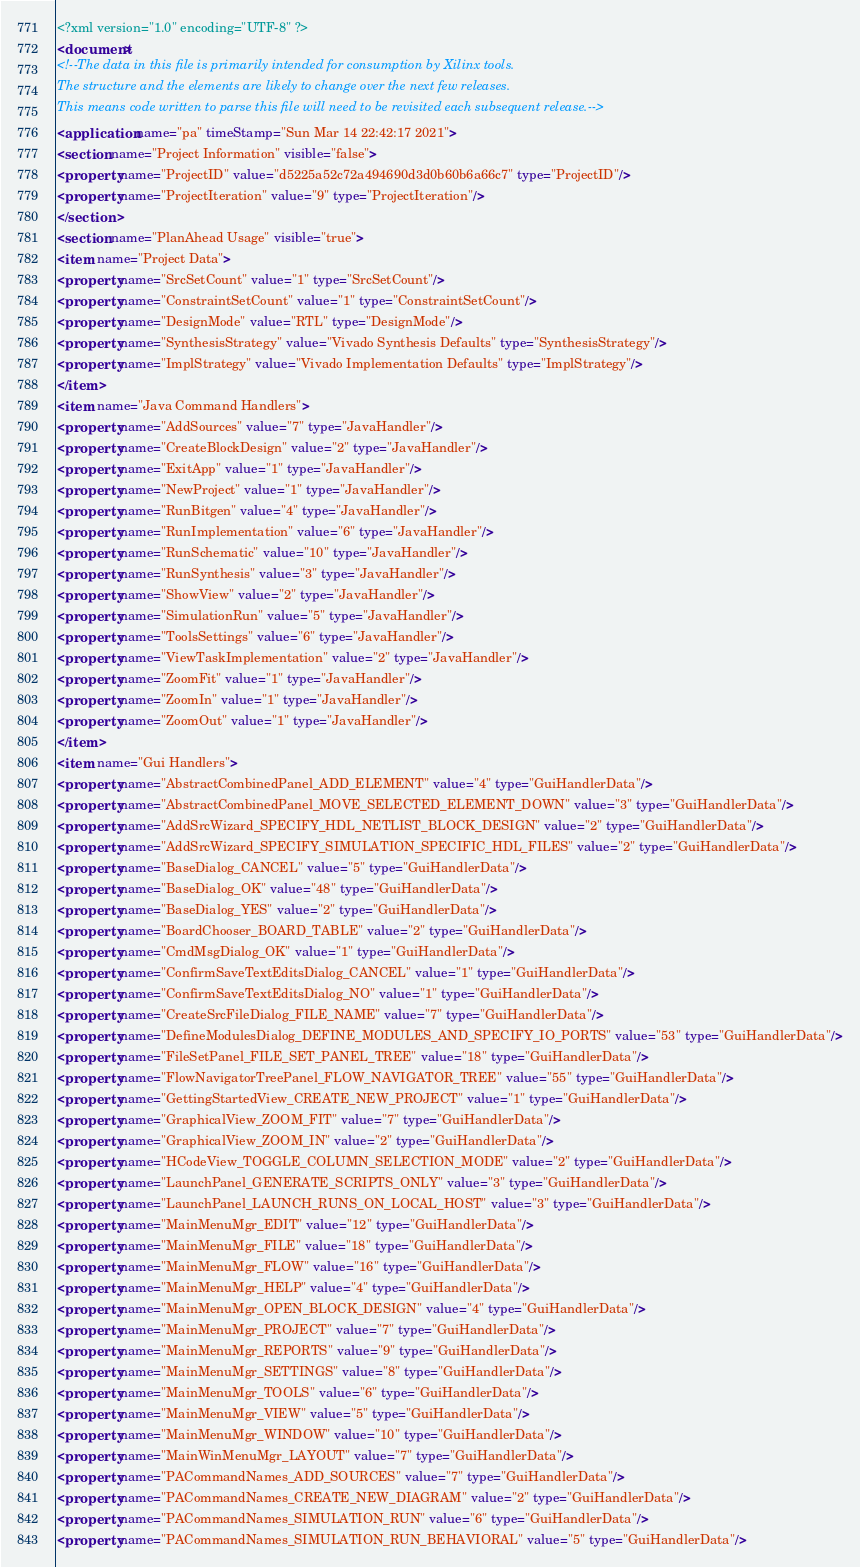Convert code to text. <code><loc_0><loc_0><loc_500><loc_500><_XML_><?xml version="1.0" encoding="UTF-8" ?>
<document>
<!--The data in this file is primarily intended for consumption by Xilinx tools.
The structure and the elements are likely to change over the next few releases.
This means code written to parse this file will need to be revisited each subsequent release.-->
<application name="pa" timeStamp="Sun Mar 14 22:42:17 2021">
<section name="Project Information" visible="false">
<property name="ProjectID" value="d5225a52c72a494690d3d0b60b6a66c7" type="ProjectID"/>
<property name="ProjectIteration" value="9" type="ProjectIteration"/>
</section>
<section name="PlanAhead Usage" visible="true">
<item name="Project Data">
<property name="SrcSetCount" value="1" type="SrcSetCount"/>
<property name="ConstraintSetCount" value="1" type="ConstraintSetCount"/>
<property name="DesignMode" value="RTL" type="DesignMode"/>
<property name="SynthesisStrategy" value="Vivado Synthesis Defaults" type="SynthesisStrategy"/>
<property name="ImplStrategy" value="Vivado Implementation Defaults" type="ImplStrategy"/>
</item>
<item name="Java Command Handlers">
<property name="AddSources" value="7" type="JavaHandler"/>
<property name="CreateBlockDesign" value="2" type="JavaHandler"/>
<property name="ExitApp" value="1" type="JavaHandler"/>
<property name="NewProject" value="1" type="JavaHandler"/>
<property name="RunBitgen" value="4" type="JavaHandler"/>
<property name="RunImplementation" value="6" type="JavaHandler"/>
<property name="RunSchematic" value="10" type="JavaHandler"/>
<property name="RunSynthesis" value="3" type="JavaHandler"/>
<property name="ShowView" value="2" type="JavaHandler"/>
<property name="SimulationRun" value="5" type="JavaHandler"/>
<property name="ToolsSettings" value="6" type="JavaHandler"/>
<property name="ViewTaskImplementation" value="2" type="JavaHandler"/>
<property name="ZoomFit" value="1" type="JavaHandler"/>
<property name="ZoomIn" value="1" type="JavaHandler"/>
<property name="ZoomOut" value="1" type="JavaHandler"/>
</item>
<item name="Gui Handlers">
<property name="AbstractCombinedPanel_ADD_ELEMENT" value="4" type="GuiHandlerData"/>
<property name="AbstractCombinedPanel_MOVE_SELECTED_ELEMENT_DOWN" value="3" type="GuiHandlerData"/>
<property name="AddSrcWizard_SPECIFY_HDL_NETLIST_BLOCK_DESIGN" value="2" type="GuiHandlerData"/>
<property name="AddSrcWizard_SPECIFY_SIMULATION_SPECIFIC_HDL_FILES" value="2" type="GuiHandlerData"/>
<property name="BaseDialog_CANCEL" value="5" type="GuiHandlerData"/>
<property name="BaseDialog_OK" value="48" type="GuiHandlerData"/>
<property name="BaseDialog_YES" value="2" type="GuiHandlerData"/>
<property name="BoardChooser_BOARD_TABLE" value="2" type="GuiHandlerData"/>
<property name="CmdMsgDialog_OK" value="1" type="GuiHandlerData"/>
<property name="ConfirmSaveTextEditsDialog_CANCEL" value="1" type="GuiHandlerData"/>
<property name="ConfirmSaveTextEditsDialog_NO" value="1" type="GuiHandlerData"/>
<property name="CreateSrcFileDialog_FILE_NAME" value="7" type="GuiHandlerData"/>
<property name="DefineModulesDialog_DEFINE_MODULES_AND_SPECIFY_IO_PORTS" value="53" type="GuiHandlerData"/>
<property name="FileSetPanel_FILE_SET_PANEL_TREE" value="18" type="GuiHandlerData"/>
<property name="FlowNavigatorTreePanel_FLOW_NAVIGATOR_TREE" value="55" type="GuiHandlerData"/>
<property name="GettingStartedView_CREATE_NEW_PROJECT" value="1" type="GuiHandlerData"/>
<property name="GraphicalView_ZOOM_FIT" value="7" type="GuiHandlerData"/>
<property name="GraphicalView_ZOOM_IN" value="2" type="GuiHandlerData"/>
<property name="HCodeView_TOGGLE_COLUMN_SELECTION_MODE" value="2" type="GuiHandlerData"/>
<property name="LaunchPanel_GENERATE_SCRIPTS_ONLY" value="3" type="GuiHandlerData"/>
<property name="LaunchPanel_LAUNCH_RUNS_ON_LOCAL_HOST" value="3" type="GuiHandlerData"/>
<property name="MainMenuMgr_EDIT" value="12" type="GuiHandlerData"/>
<property name="MainMenuMgr_FILE" value="18" type="GuiHandlerData"/>
<property name="MainMenuMgr_FLOW" value="16" type="GuiHandlerData"/>
<property name="MainMenuMgr_HELP" value="4" type="GuiHandlerData"/>
<property name="MainMenuMgr_OPEN_BLOCK_DESIGN" value="4" type="GuiHandlerData"/>
<property name="MainMenuMgr_PROJECT" value="7" type="GuiHandlerData"/>
<property name="MainMenuMgr_REPORTS" value="9" type="GuiHandlerData"/>
<property name="MainMenuMgr_SETTINGS" value="8" type="GuiHandlerData"/>
<property name="MainMenuMgr_TOOLS" value="6" type="GuiHandlerData"/>
<property name="MainMenuMgr_VIEW" value="5" type="GuiHandlerData"/>
<property name="MainMenuMgr_WINDOW" value="10" type="GuiHandlerData"/>
<property name="MainWinMenuMgr_LAYOUT" value="7" type="GuiHandlerData"/>
<property name="PACommandNames_ADD_SOURCES" value="7" type="GuiHandlerData"/>
<property name="PACommandNames_CREATE_NEW_DIAGRAM" value="2" type="GuiHandlerData"/>
<property name="PACommandNames_SIMULATION_RUN" value="6" type="GuiHandlerData"/>
<property name="PACommandNames_SIMULATION_RUN_BEHAVIORAL" value="5" type="GuiHandlerData"/></code> 